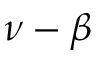Convert formula to latex. <formula><loc_0><loc_0><loc_500><loc_500>\nu - \beta</formula> 